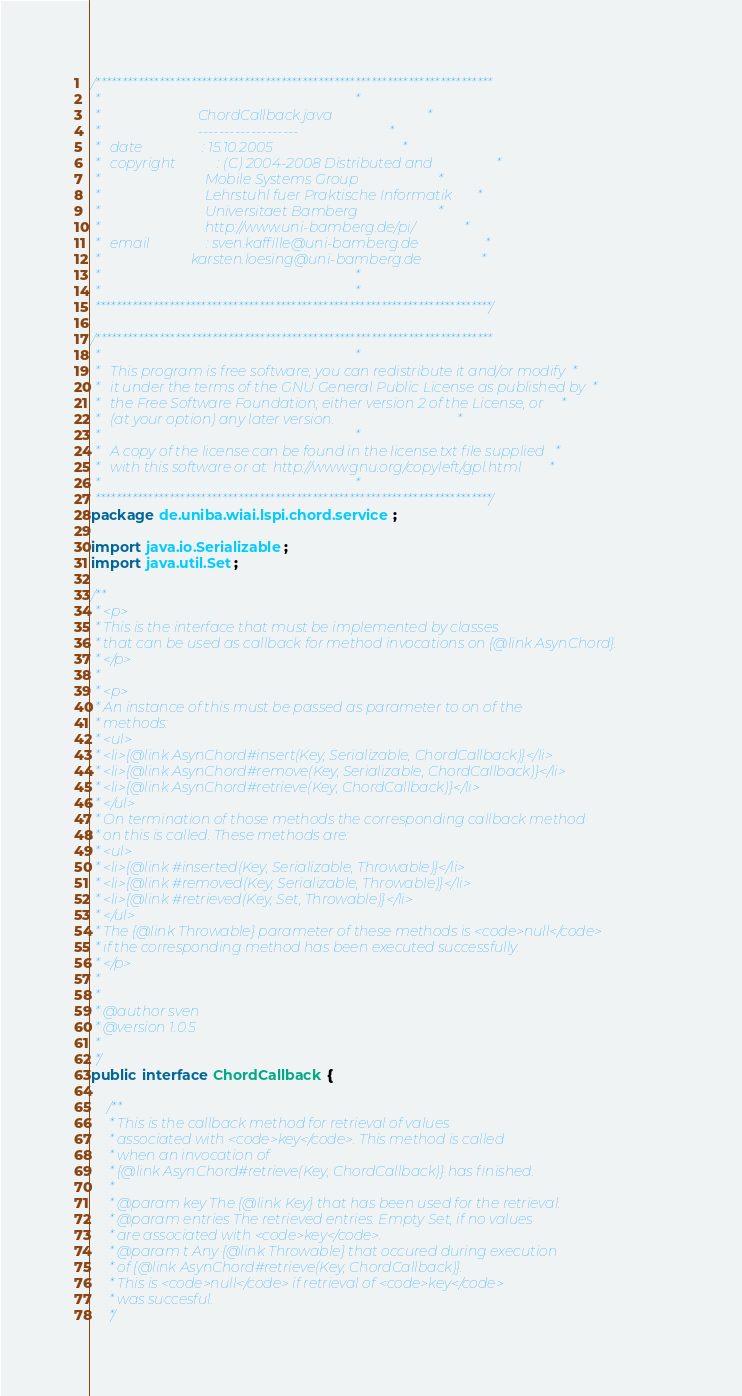Convert code to text. <code><loc_0><loc_0><loc_500><loc_500><_Java_>/***************************************************************************
 *                                                                         *
 *                            ChordCallback.java                           *
 *                            -------------------                          *
 *   date                 : 15.10.2005                                     *
 *   copyright            : (C) 2004-2008 Distributed and                  *
 *                              Mobile Systems Group                       *
 *                              Lehrstuhl fuer Praktische Informatik       *
 *                              Universitaet Bamberg                       *
 *                              http://www.uni-bamberg.de/pi/              *
 *   email                : sven.kaffille@uni-bamberg.de                   *
 *                          karsten.loesing@uni-bamberg.de                 *
 *                                                                         *
 *                                                                         *
 ***************************************************************************/

/***************************************************************************
 *                                                                         *
 *   This program is free software; you can redistribute it and/or modify  *
 *   it under the terms of the GNU General Public License as published by  *
 *   the Free Software Foundation; either version 2 of the License, or     *
 *   (at your option) any later version.                                   *
 *                                                                         *
 *   A copy of the license can be found in the license.txt file supplied   *
 *   with this software or at: http://www.gnu.org/copyleft/gpl.html        *
 *                                                                         *
 ***************************************************************************/
package de.uniba.wiai.lspi.chord.service;

import java.io.Serializable;
import java.util.Set;

/**
 * <p>
 * This is the interface that must be implemented by classes 
 * that can be used as callback for method invocations on {@link AsynChord}.
 * </p> 
 * 
 * <p>
 * An instance of this must be passed as parameter to on of the 
 * methods:
 * <ul>
 * <li>{@link AsynChord#insert(Key, Serializable, ChordCallback)}</li>
 * <li>{@link AsynChord#remove(Key, Serializable, ChordCallback)}</li>
 * <li>{@link AsynChord#retrieve(Key, ChordCallback)}</li>
 * </ul>
 * On termination of those methods the corresponding callback method 
 * on this is called. These methods are: 
 * <ul>
 * <li>{@link #inserted(Key, Serializable, Throwable)}</li>
 * <li>{@link #removed(Key, Serializable, Throwable)}</li>
 * <li>{@link #retrieved(Key, Set, Throwable)}</li>
 * </ul>
 * The {@link Throwable} parameter of these methods is <code>null</code> 
 * if the corresponding method has been executed successfully. 
 * </p>
 * 
 *  
 * @author sven
 * @version 1.0.5
 *
 */
public interface ChordCallback {

	/**
	 * This is the callback method for retrieval of values 
	 * associated with <code>key</code>. This method is called 
	 * when an invocation of 
	 * {@link AsynChord#retrieve(Key, ChordCallback)} has finished.   
	 * 
	 * @param key The {@link Key} that has been used for the retrieval.   
	 * @param entries The retrieved entries. Empty Set, if no values 
	 * are associated with <code>key</code>. 
	 * @param t Any {@link Throwable} that occured during execution 
	 * of {@link AsynChord#retrieve(Key, ChordCallback)}. 
	 * This is <code>null</code> if retrieval of <code>key</code> 
	 * was succesful.
	 */</code> 